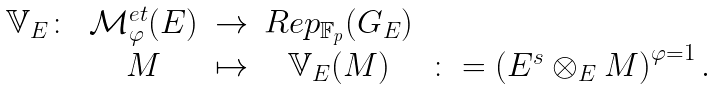Convert formula to latex. <formula><loc_0><loc_0><loc_500><loc_500>\begin{matrix} \mathbb { V } _ { E } \colon & \mathcal { M } _ { \varphi } ^ { e t } ( E ) & \to & R e p _ { \mathbb { F } _ { p } } ( G _ { E } ) & \\ & M & \mapsto & \mathbb { V } _ { E } ( M ) & \colon = \left ( E ^ { s } \otimes _ { E } M \right ) ^ { \varphi = 1 } . \end{matrix}</formula> 